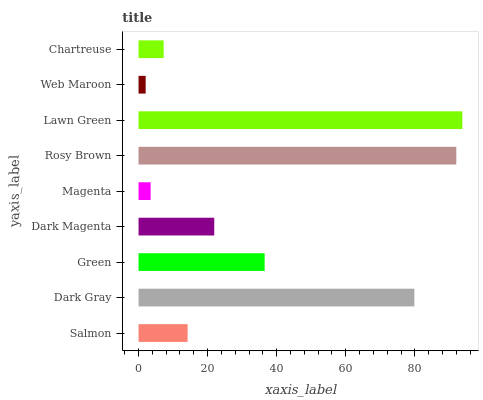Is Web Maroon the minimum?
Answer yes or no. Yes. Is Lawn Green the maximum?
Answer yes or no. Yes. Is Dark Gray the minimum?
Answer yes or no. No. Is Dark Gray the maximum?
Answer yes or no. No. Is Dark Gray greater than Salmon?
Answer yes or no. Yes. Is Salmon less than Dark Gray?
Answer yes or no. Yes. Is Salmon greater than Dark Gray?
Answer yes or no. No. Is Dark Gray less than Salmon?
Answer yes or no. No. Is Dark Magenta the high median?
Answer yes or no. Yes. Is Dark Magenta the low median?
Answer yes or no. Yes. Is Salmon the high median?
Answer yes or no. No. Is Rosy Brown the low median?
Answer yes or no. No. 